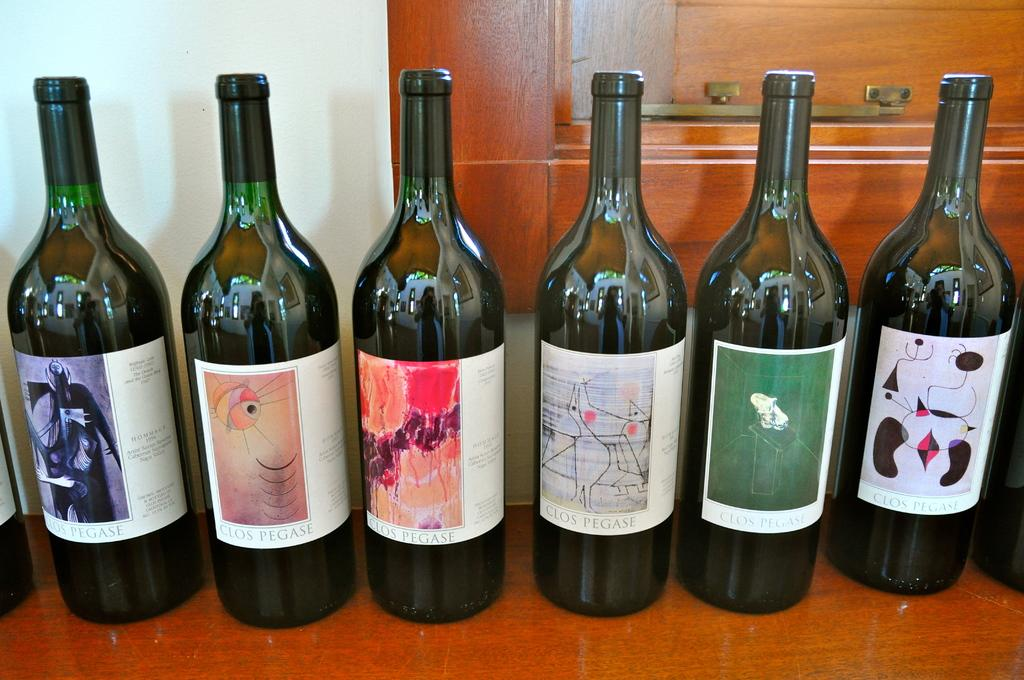What objects are visible in the image? There are bottles in the image. Where are the bottles located? The bottles are placed on a surface. What can be seen in the background of the image? There is a wall in the image. What type of door is present in the image? There is a wooden door in the image. What country is depicted in the image? There is no country depicted in the image; it only features bottles, a surface, a wall, and a wooden door. 